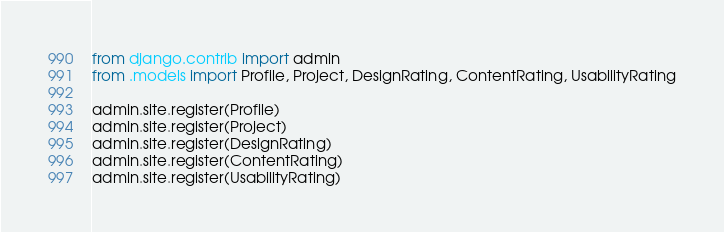<code> <loc_0><loc_0><loc_500><loc_500><_Python_>from django.contrib import admin
from .models import Profile, Project, DesignRating, ContentRating, UsabilityRating

admin.site.register(Profile)
admin.site.register(Project)
admin.site.register(DesignRating)
admin.site.register(ContentRating)
admin.site.register(UsabilityRating)
</code> 